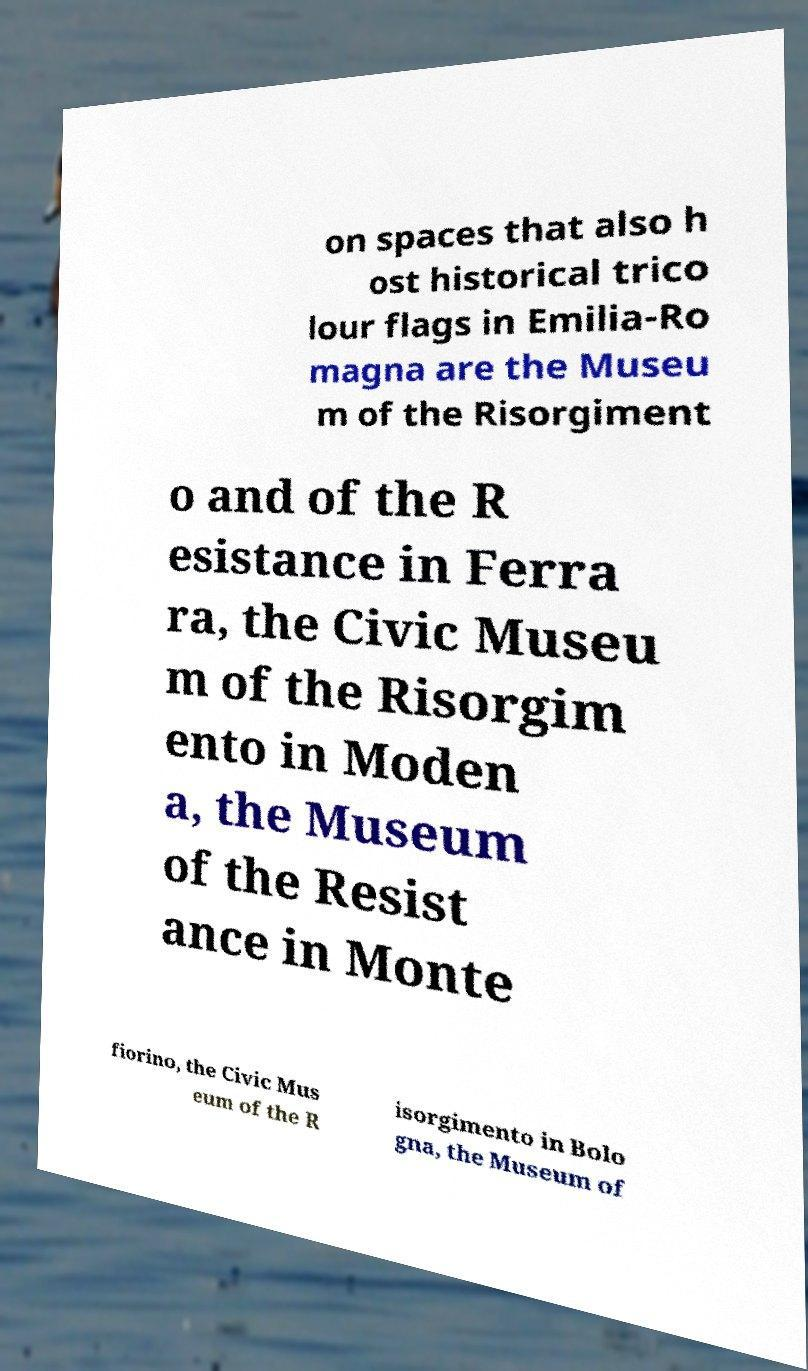For documentation purposes, I need the text within this image transcribed. Could you provide that? on spaces that also h ost historical trico lour flags in Emilia-Ro magna are the Museu m of the Risorgiment o and of the R esistance in Ferra ra, the Civic Museu m of the Risorgim ento in Moden a, the Museum of the Resist ance in Monte fiorino, the Civic Mus eum of the R isorgimento in Bolo gna, the Museum of 